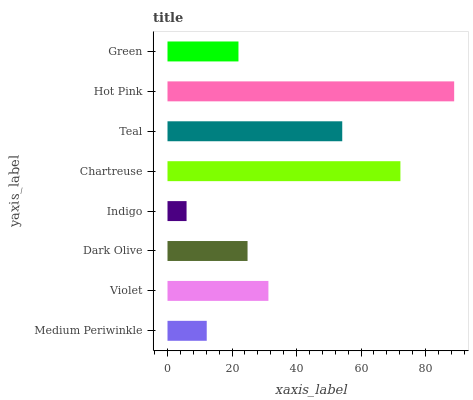Is Indigo the minimum?
Answer yes or no. Yes. Is Hot Pink the maximum?
Answer yes or no. Yes. Is Violet the minimum?
Answer yes or no. No. Is Violet the maximum?
Answer yes or no. No. Is Violet greater than Medium Periwinkle?
Answer yes or no. Yes. Is Medium Periwinkle less than Violet?
Answer yes or no. Yes. Is Medium Periwinkle greater than Violet?
Answer yes or no. No. Is Violet less than Medium Periwinkle?
Answer yes or no. No. Is Violet the high median?
Answer yes or no. Yes. Is Dark Olive the low median?
Answer yes or no. Yes. Is Teal the high median?
Answer yes or no. No. Is Indigo the low median?
Answer yes or no. No. 